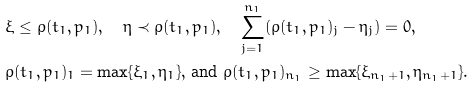Convert formula to latex. <formula><loc_0><loc_0><loc_500><loc_500>& \xi \leq \rho ( t _ { 1 } , p _ { 1 } ) , \quad \eta \prec \rho ( t _ { 1 } , p _ { 1 } ) , \quad \sum _ { j = 1 } ^ { n _ { 1 } } ( \rho ( t _ { 1 } , p _ { 1 } ) _ { j } - \eta _ { j } ) = 0 , \\ & \rho ( t _ { 1 } , p _ { 1 } ) _ { 1 } = \max \{ \xi _ { 1 } , \eta _ { 1 } \} , \, \text {and } \rho ( t _ { 1 } , p _ { 1 } ) _ { n _ { 1 } } \geq \max \{ \xi _ { n _ { 1 } + 1 } , \eta _ { n _ { 1 } + 1 } \} .</formula> 